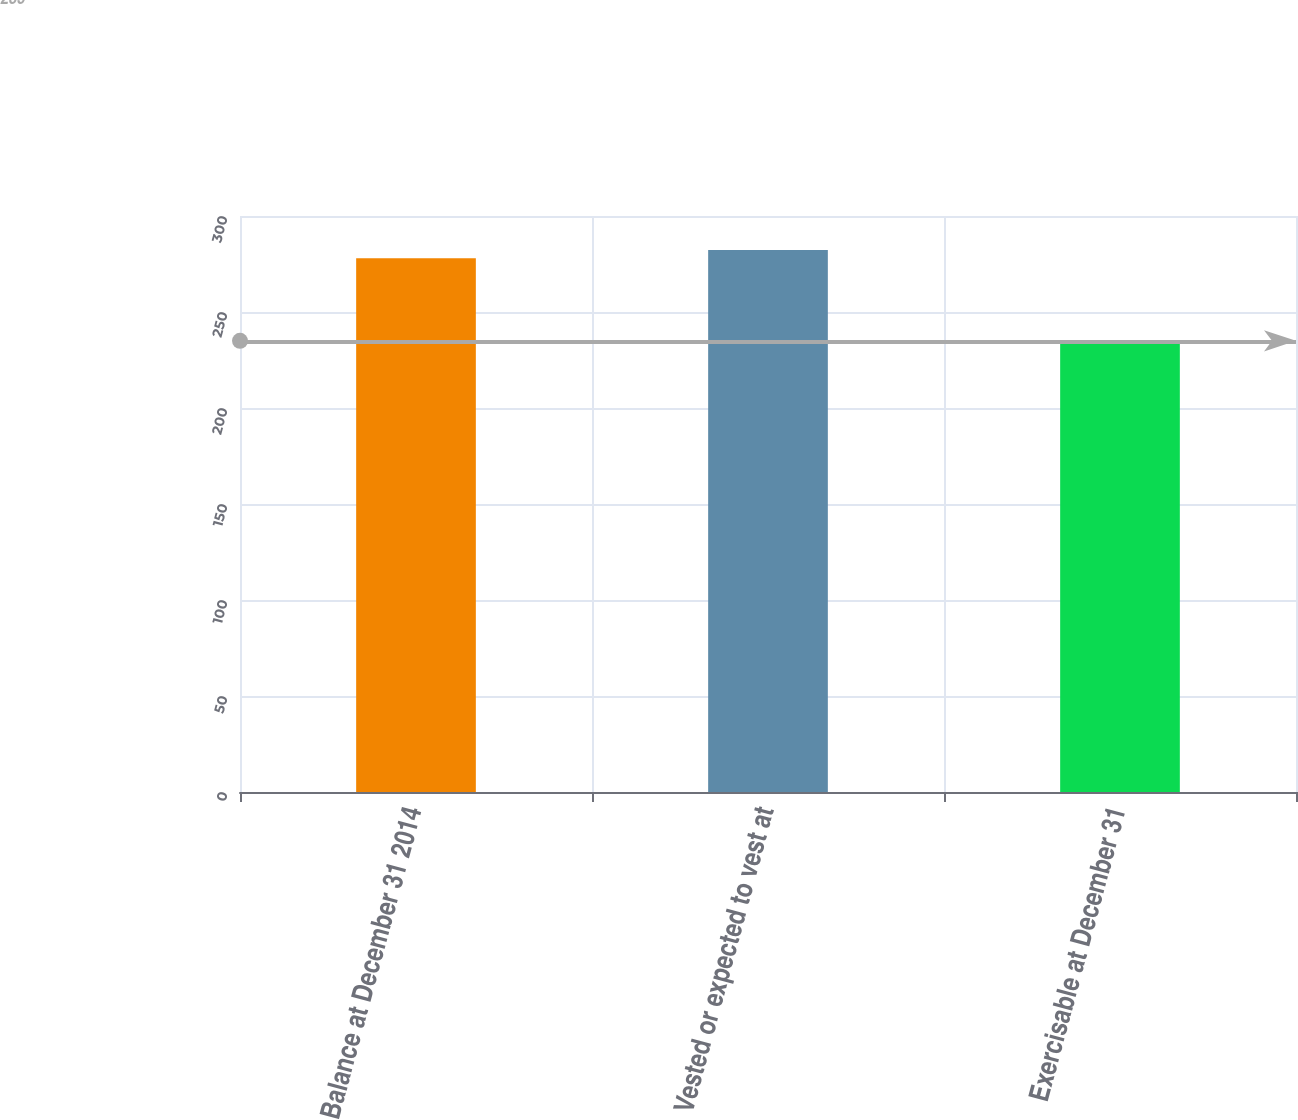<chart> <loc_0><loc_0><loc_500><loc_500><bar_chart><fcel>Balance at December 31 2014<fcel>Vested or expected to vest at<fcel>Exercisable at December 31<nl><fcel>278<fcel>282.3<fcel>235<nl></chart> 